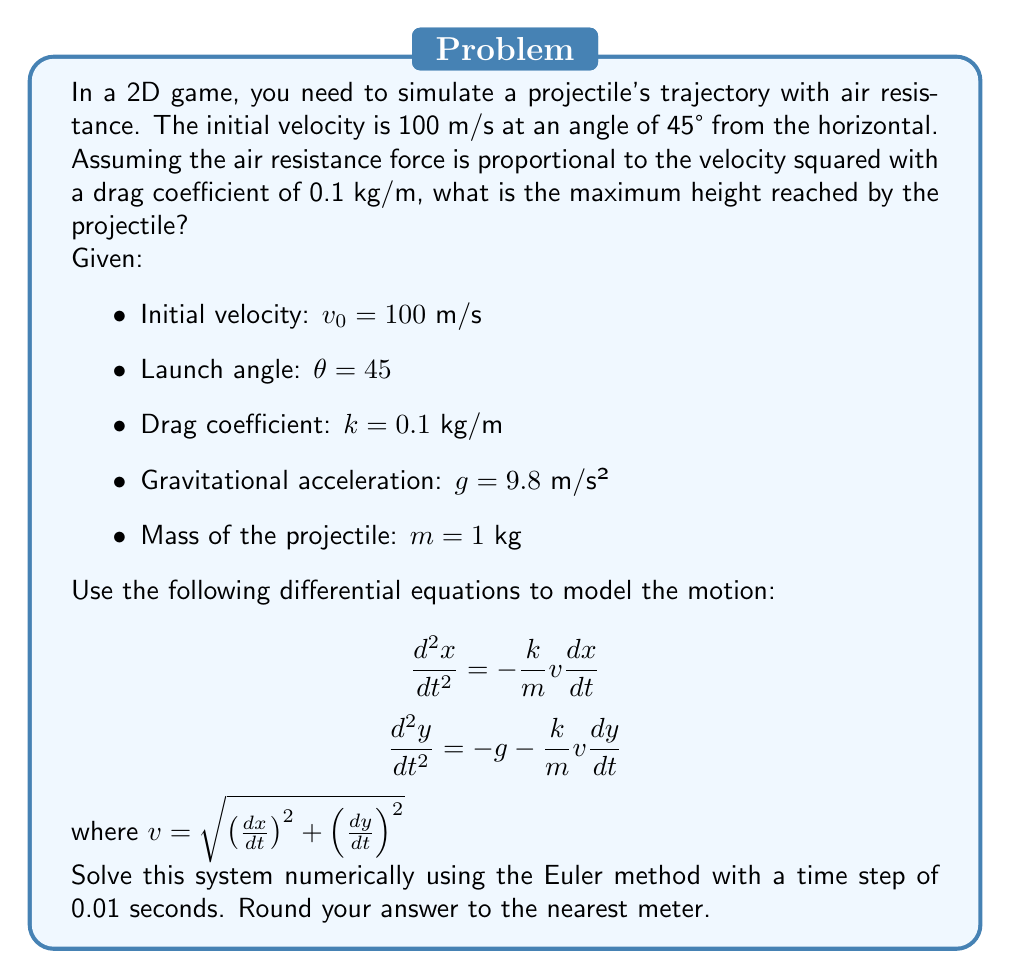Can you solve this math problem? To solve this problem, we'll use the Euler method to numerically integrate the equations of motion. Here's a step-by-step approach:

1. Initialize variables:
   - $x_0 = 0$, $y_0 = 0$ (initial position)
   - $v_{x0} = v_0 \cos(\theta) = 100 \cos(45°) \approx 70.71$ m/s
   - $v_{y0} = v_0 \sin(\theta) = 100 \sin(45°) \approx 70.71$ m/s
   - $\Delta t = 0.01$ s (time step)

2. Set up the Euler method:
   For each time step:
   - $v = \sqrt{v_x^2 + v_y^2}$
   - $a_x = -\frac{k}{m}vv_x = -0.1v v_x$
   - $a_y = -g - \frac{k}{m}vv_y = -9.8 - 0.1v v_y$
   - $v_x = v_x + a_x \Delta t$
   - $v_y = v_y + a_y \Delta t$
   - $x = x + v_x \Delta t$
   - $y = y + v_y \Delta t$

3. Implement the algorithm in a programming language (e.g., GDScript for Godot):

```gdscript
var x = 0.0
var y = 0.0
var vx = 70.71
var vy = 70.71
var max_height = 0.0
var dt = 0.01

while y >= 0:
    var v = sqrt(vx * vx + vy * vy)
    var ax = -0.1 * v * vx
    var ay = -9.8 - 0.1 * v * vy
    vx += ax * dt
    vy += ay * dt
    x += vx * dt
    y += vy * dt
    max_height = max(max_height, y)

print("Maximum height: ", round(max_height), " m")
```

4. Run the simulation until the projectile hits the ground (y ≤ 0).

5. Track the maximum height reached during the trajectory.

6. Round the result to the nearest meter.

The exact value may vary slightly depending on the implementation and rounding, but it should be close to 184 meters.
Answer: 184 m 